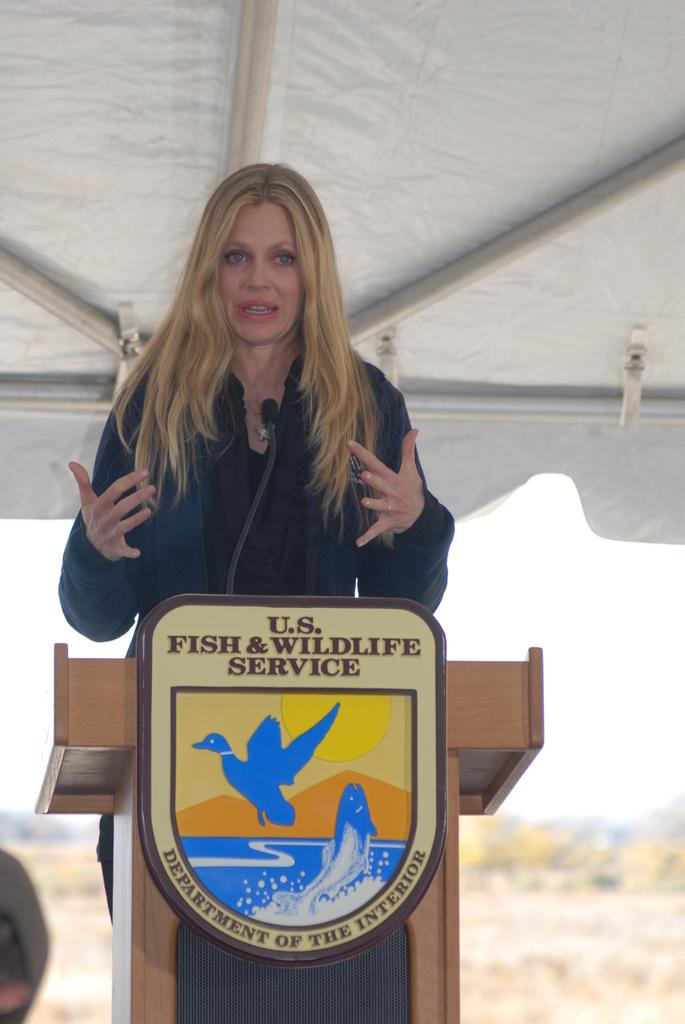Provide a one-sentence caption for the provided image. a woman standing in front of a sign that says u.s. fish & wildlife service. 